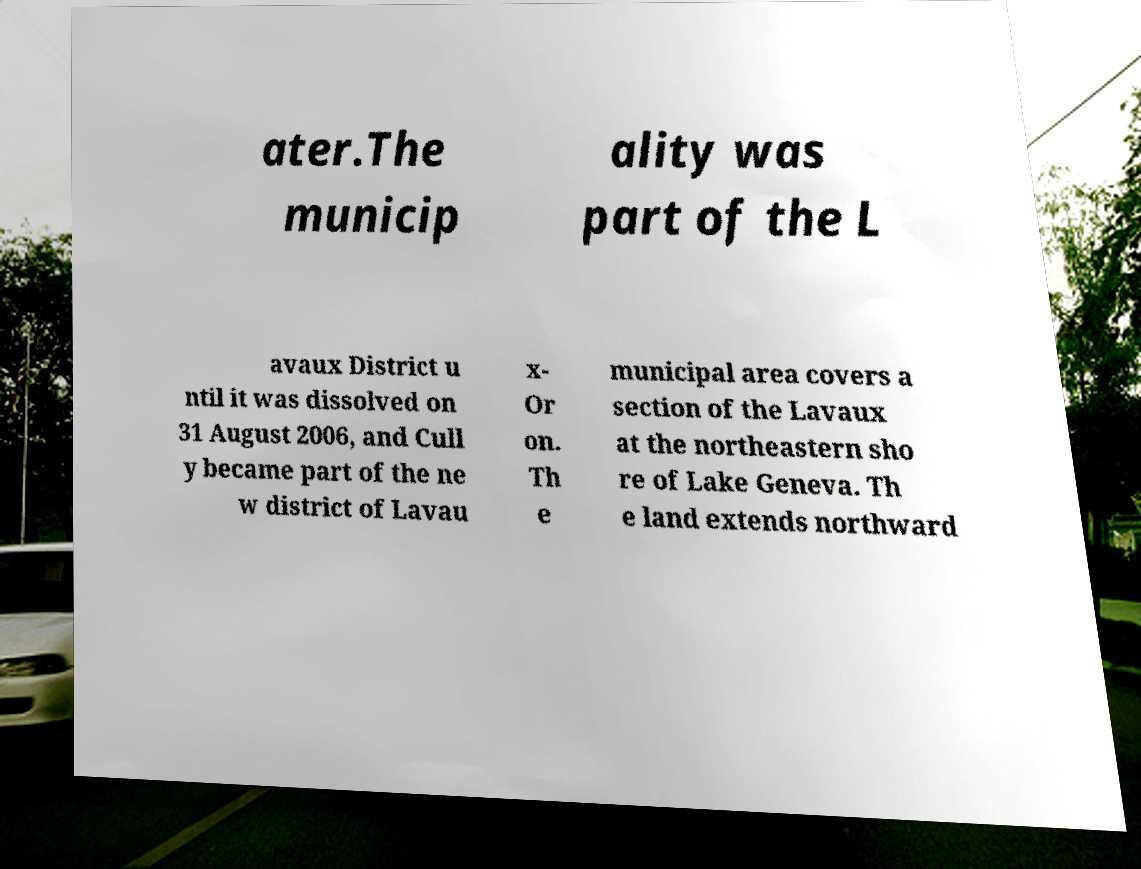Could you extract and type out the text from this image? ater.The municip ality was part of the L avaux District u ntil it was dissolved on 31 August 2006, and Cull y became part of the ne w district of Lavau x- Or on. Th e municipal area covers a section of the Lavaux at the northeastern sho re of Lake Geneva. Th e land extends northward 